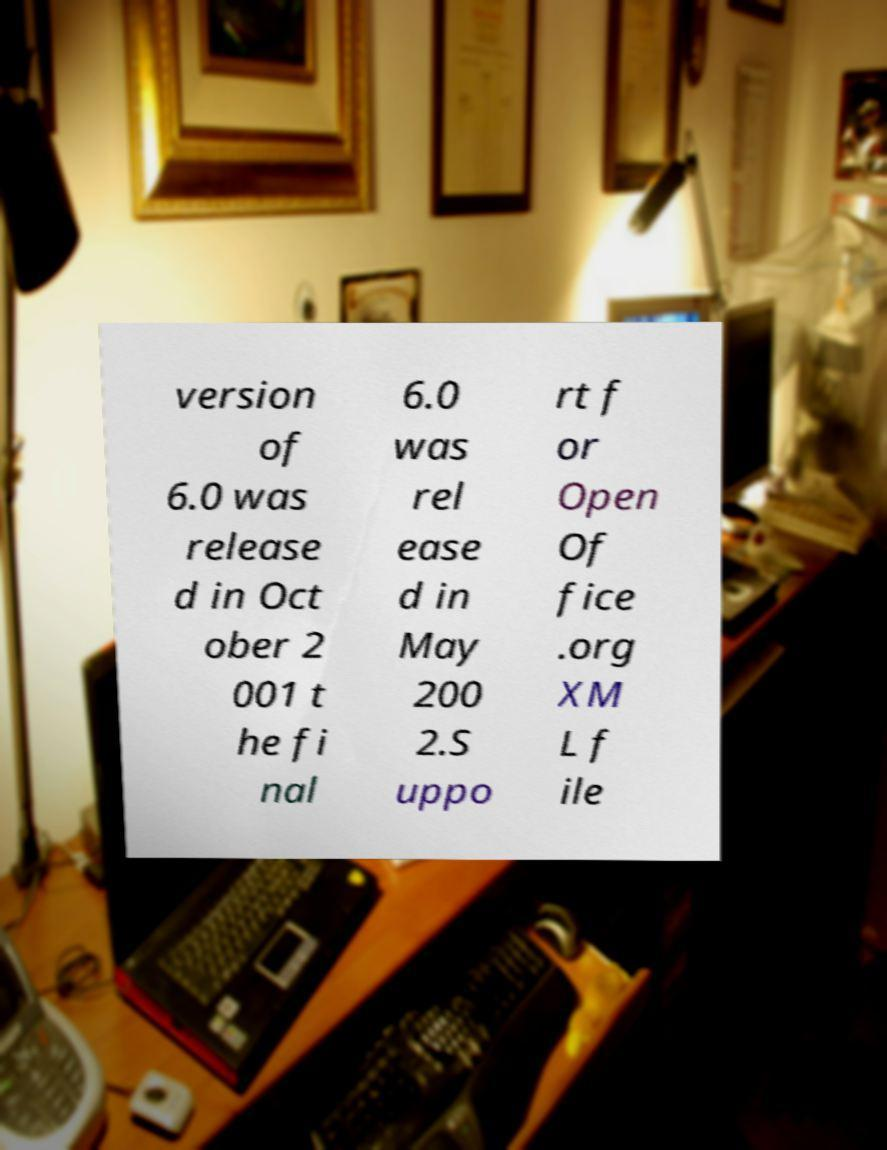What messages or text are displayed in this image? I need them in a readable, typed format. version of 6.0 was release d in Oct ober 2 001 t he fi nal 6.0 was rel ease d in May 200 2.S uppo rt f or Open Of fice .org XM L f ile 